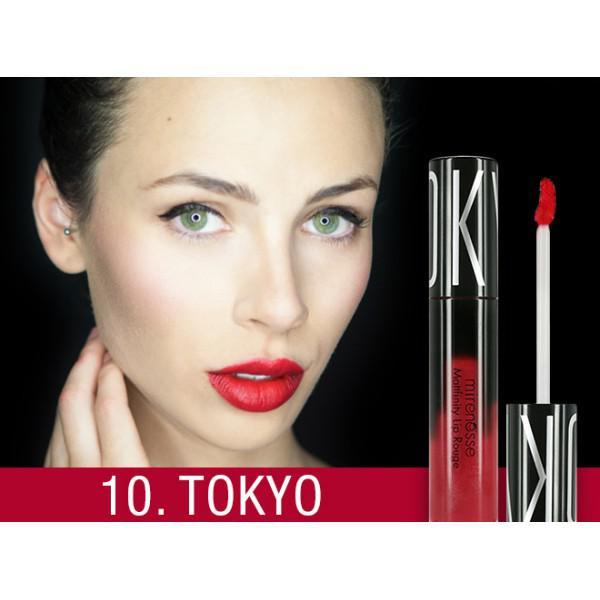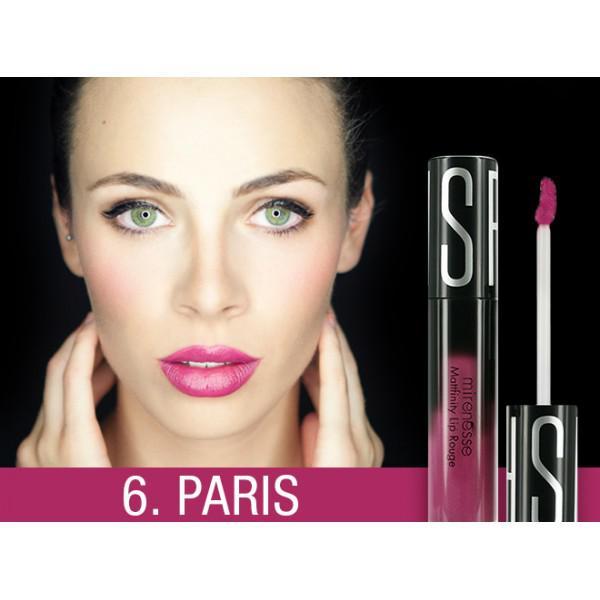The first image is the image on the left, the second image is the image on the right. Assess this claim about the two images: "Both images show models with non-pursed open mouths with no tongue showing.". Correct or not? Answer yes or no. Yes. The first image is the image on the left, the second image is the image on the right. Given the left and right images, does the statement "There is exactly one hand visible in one of the images" hold true? Answer yes or no. Yes. 